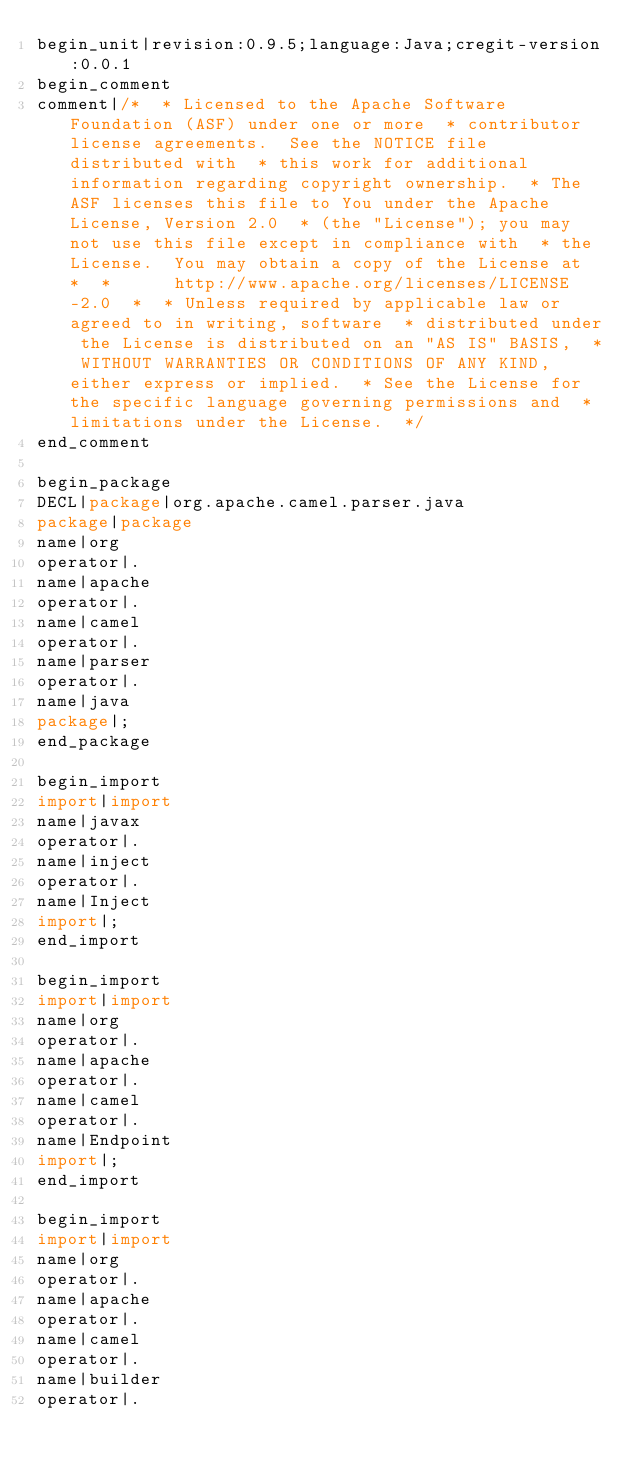<code> <loc_0><loc_0><loc_500><loc_500><_Java_>begin_unit|revision:0.9.5;language:Java;cregit-version:0.0.1
begin_comment
comment|/*  * Licensed to the Apache Software Foundation (ASF) under one or more  * contributor license agreements.  See the NOTICE file distributed with  * this work for additional information regarding copyright ownership.  * The ASF licenses this file to You under the Apache License, Version 2.0  * (the "License"); you may not use this file except in compliance with  * the License.  You may obtain a copy of the License at  *  *      http://www.apache.org/licenses/LICENSE-2.0  *  * Unless required by applicable law or agreed to in writing, software  * distributed under the License is distributed on an "AS IS" BASIS,  * WITHOUT WARRANTIES OR CONDITIONS OF ANY KIND, either express or implied.  * See the License for the specific language governing permissions and  * limitations under the License.  */
end_comment

begin_package
DECL|package|org.apache.camel.parser.java
package|package
name|org
operator|.
name|apache
operator|.
name|camel
operator|.
name|parser
operator|.
name|java
package|;
end_package

begin_import
import|import
name|javax
operator|.
name|inject
operator|.
name|Inject
import|;
end_import

begin_import
import|import
name|org
operator|.
name|apache
operator|.
name|camel
operator|.
name|Endpoint
import|;
end_import

begin_import
import|import
name|org
operator|.
name|apache
operator|.
name|camel
operator|.
name|builder
operator|.</code> 